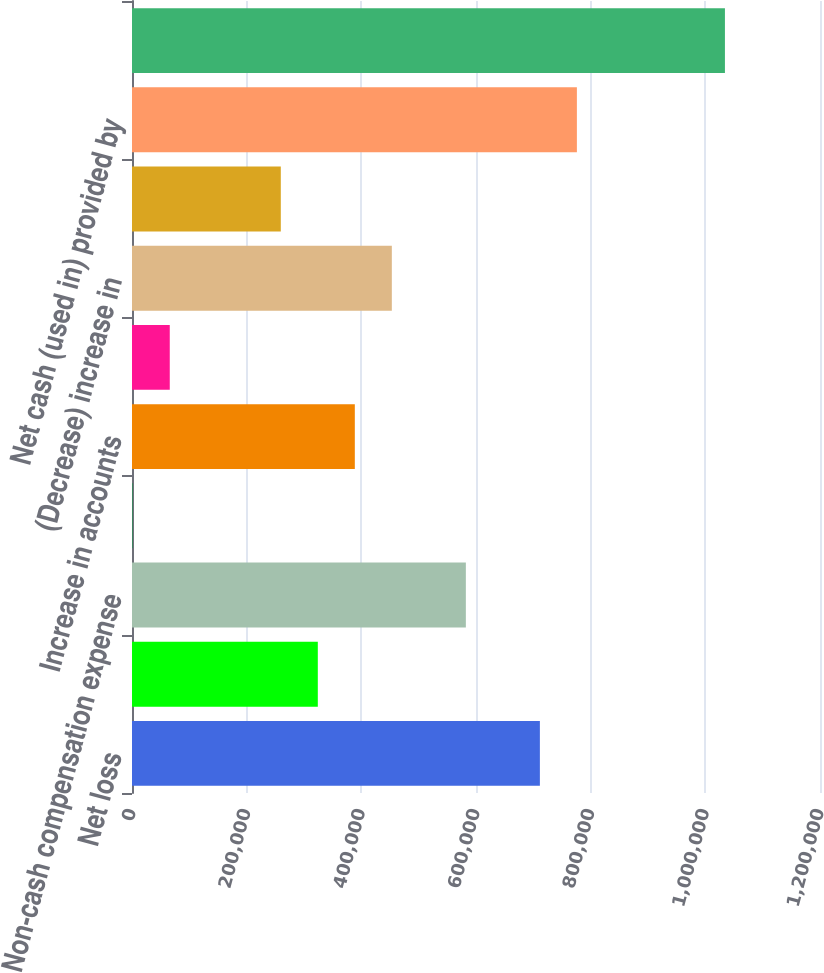<chart> <loc_0><loc_0><loc_500><loc_500><bar_chart><fcel>Net loss<fcel>Depreciation and amortization<fcel>Non-cash compensation expense<fcel>Net realized (gain) loss on<fcel>Increase in accounts<fcel>Increase in prepaid expenses<fcel>(Decrease) increase in<fcel>Total adjustments<fcel>Net cash (used in) provided by<fcel>Purchases of marketable<nl><fcel>711416<fcel>324086<fcel>582306<fcel>1310<fcel>388641<fcel>65865.1<fcel>453196<fcel>259530<fcel>775971<fcel>1.03419e+06<nl></chart> 